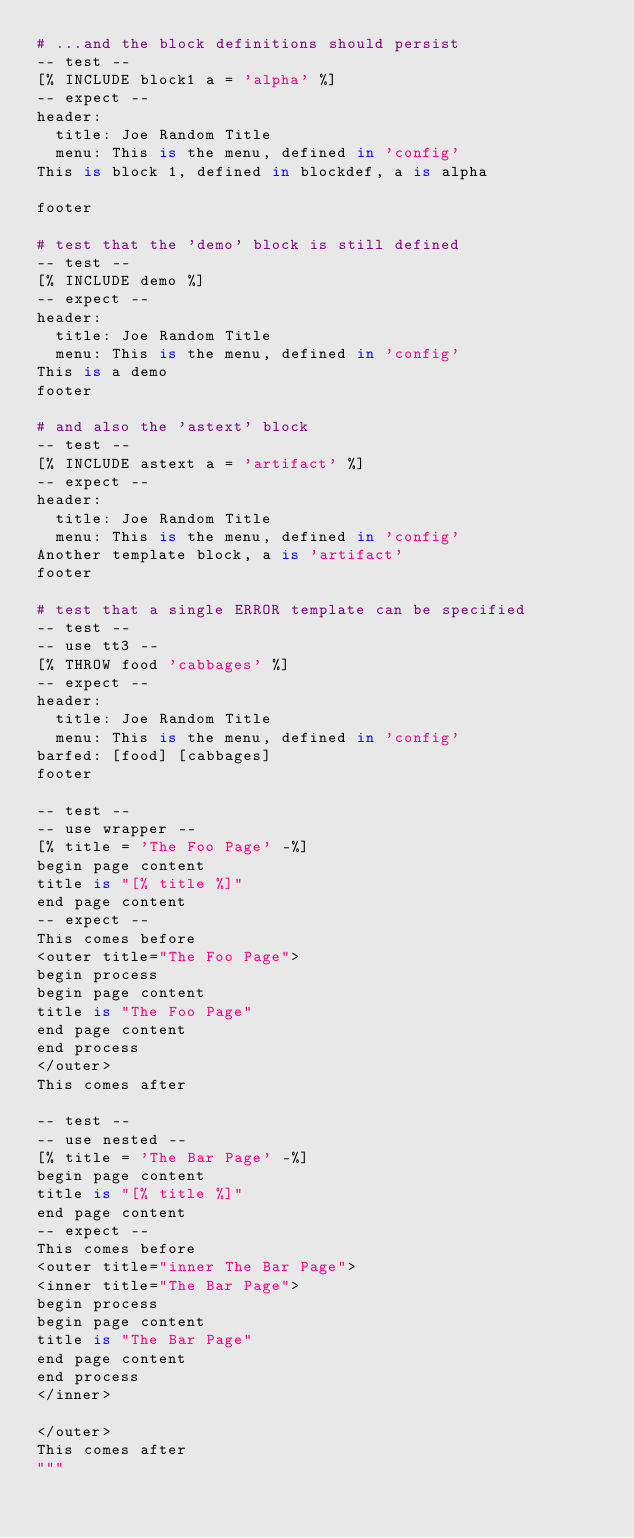Convert code to text. <code><loc_0><loc_0><loc_500><loc_500><_Python_># ...and the block definitions should persist
-- test --
[% INCLUDE block1 a = 'alpha' %]
-- expect --
header:
  title: Joe Random Title
  menu: This is the menu, defined in 'config'
This is block 1, defined in blockdef, a is alpha

footer

# test that the 'demo' block is still defined
-- test --
[% INCLUDE demo %]
-- expect --
header:
  title: Joe Random Title
  menu: This is the menu, defined in 'config'
This is a demo
footer

# and also the 'astext' block
-- test --
[% INCLUDE astext a = 'artifact' %]
-- expect --
header:
  title: Joe Random Title
  menu: This is the menu, defined in 'config'
Another template block, a is 'artifact'
footer

# test that a single ERROR template can be specified
-- test --
-- use tt3 --
[% THROW food 'cabbages' %]
-- expect --
header:
  title: Joe Random Title
  menu: This is the menu, defined in 'config'
barfed: [food] [cabbages]
footer

-- test --
-- use wrapper --
[% title = 'The Foo Page' -%]
begin page content
title is "[% title %]"
end page content
-- expect --
This comes before
<outer title="The Foo Page">
begin process
begin page content
title is "The Foo Page"
end page content
end process
</outer>
This comes after

-- test --
-- use nested --
[% title = 'The Bar Page' -%]
begin page content
title is "[% title %]"
end page content
-- expect --
This comes before
<outer title="inner The Bar Page">
<inner title="The Bar Page">
begin process
begin page content
title is "The Bar Page"
end page content
end process
</inner>

</outer>
This comes after
"""

</code> 